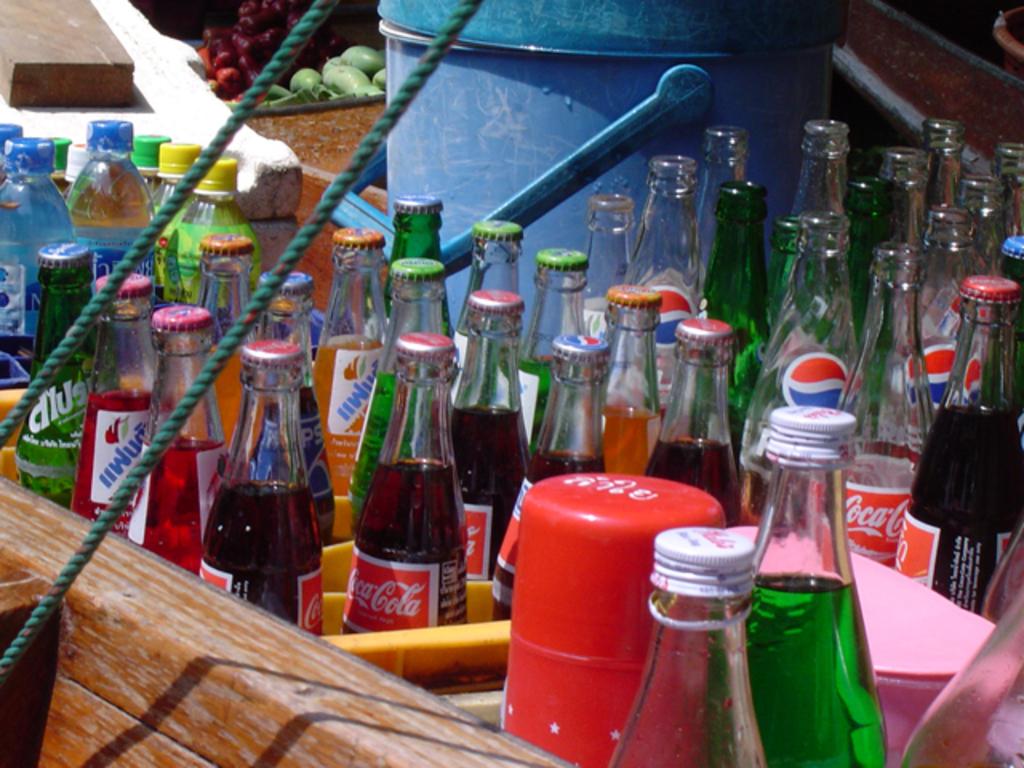What kind of soda is this?
Offer a very short reply. Coca cola. 